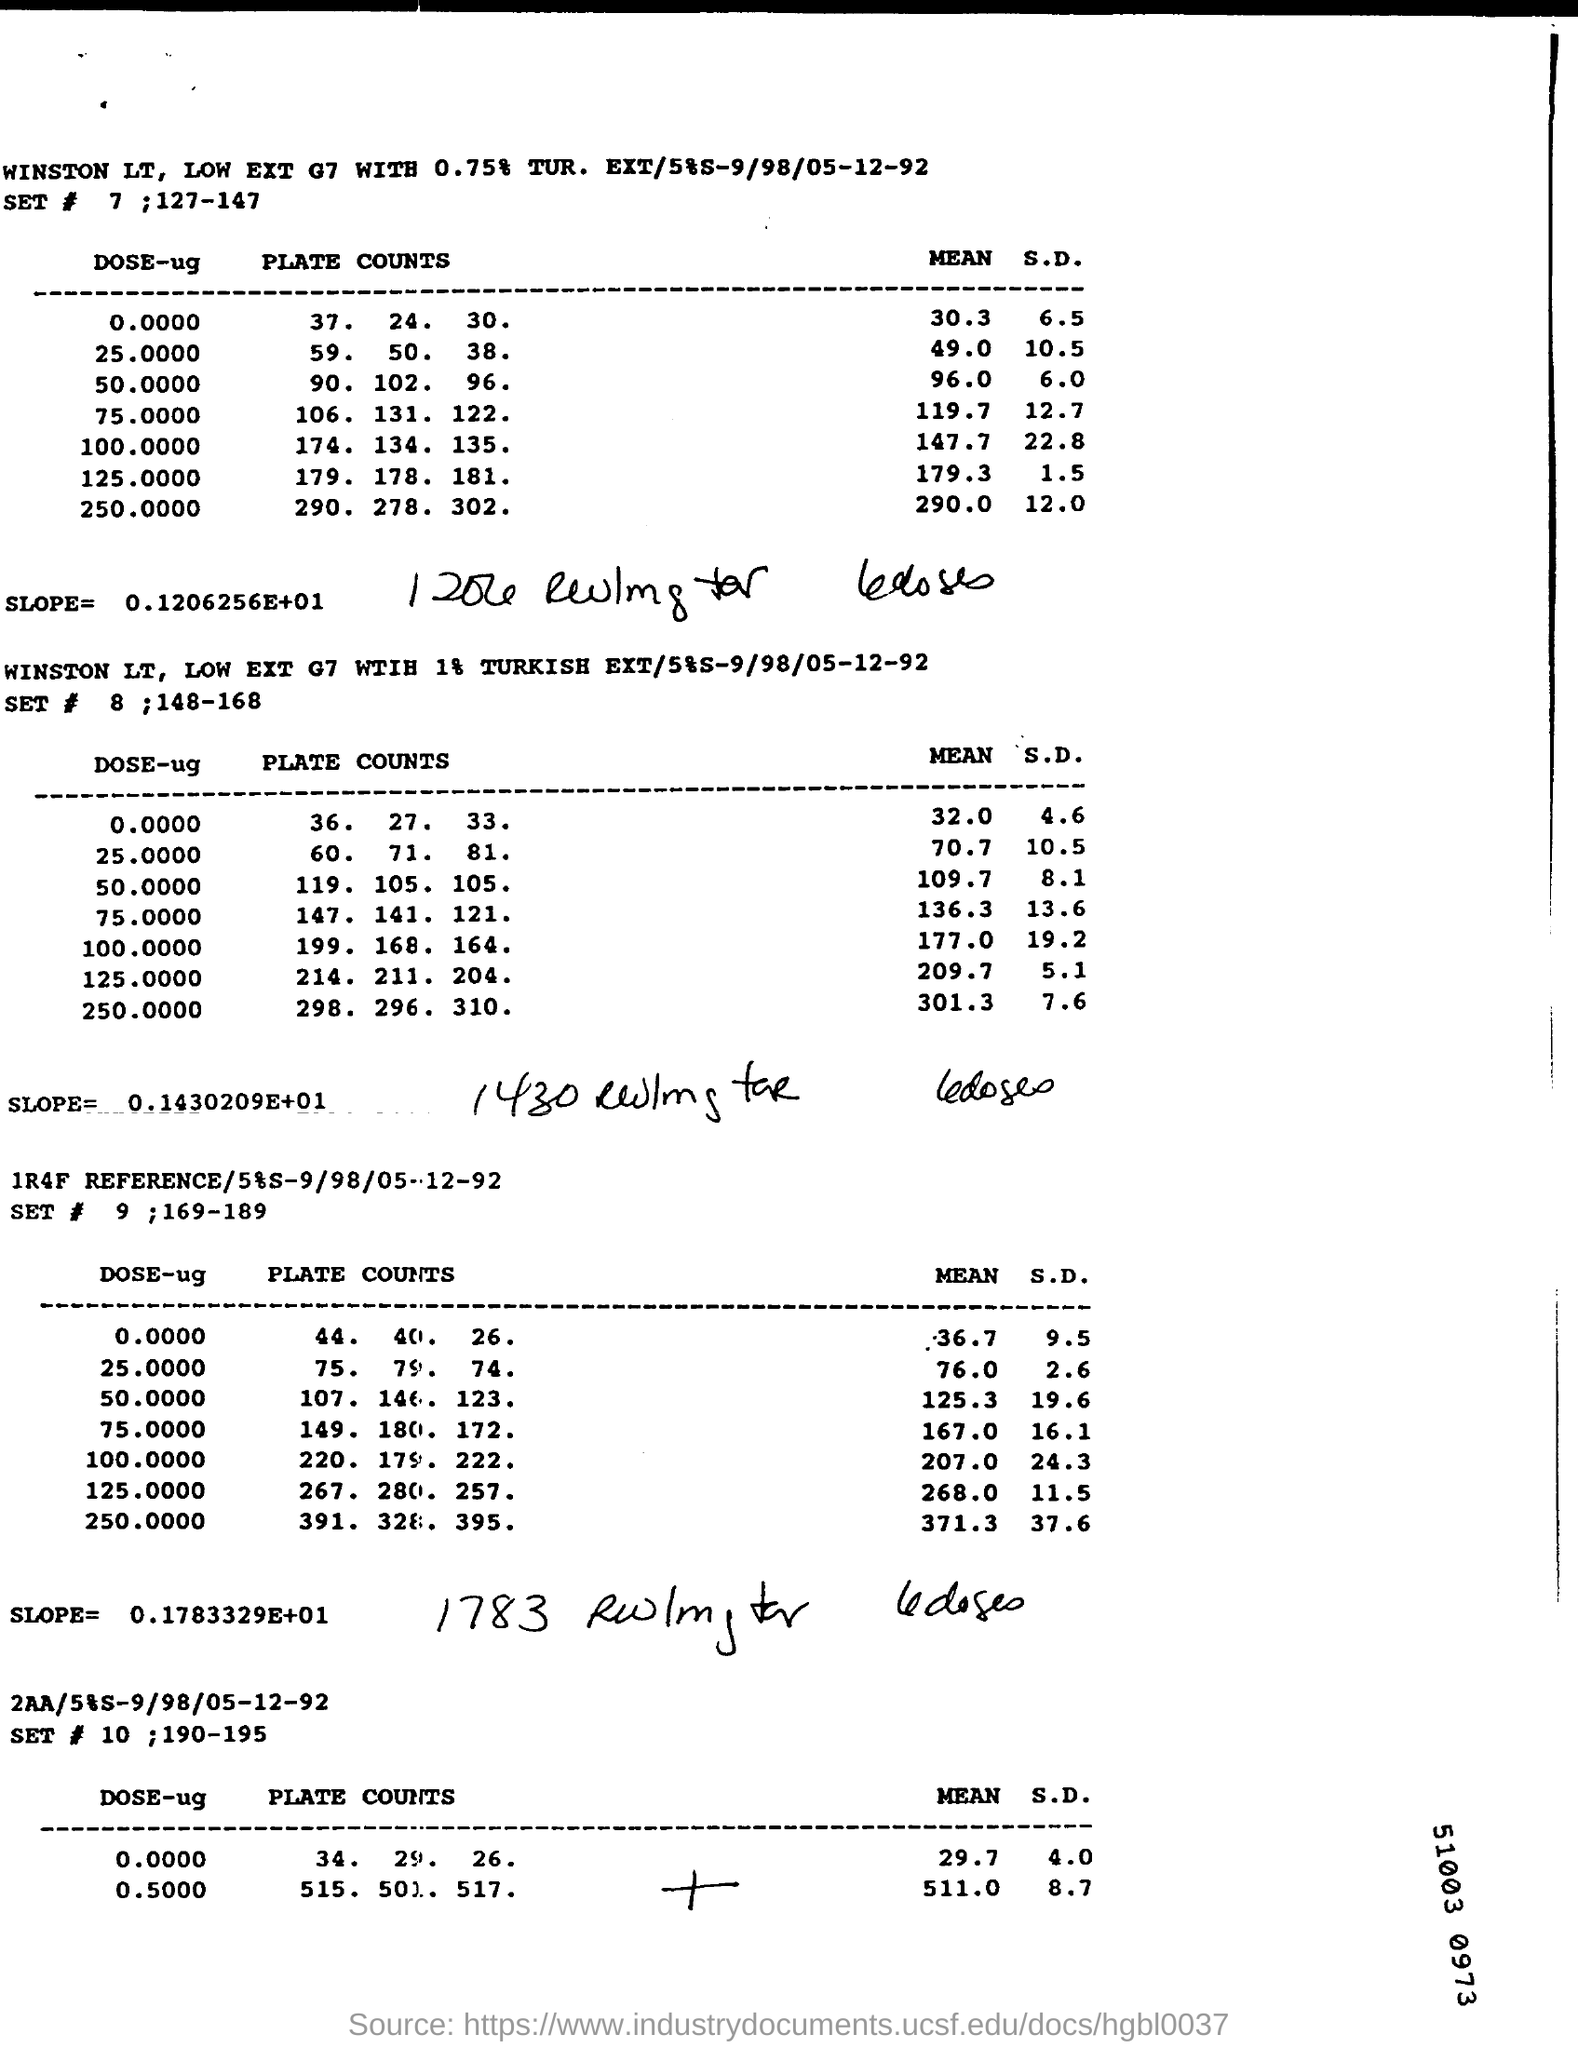Mention a couple of crucial points in this snapshot. The heading for the third table is "1R4F Reference/5%S-9/98/05-12-92. The SET# number given to the second table is 8. The heading for the second table is "WINSTON LT, LOW EXT G7 WITH 1% TURKISH EXT/5%S-9/98/05-12-92. The slope, or the rate of change, of the first table is 0.1206256, which is a large number expressed in scientific notation. The SET # number given to the fourth table is 10. 